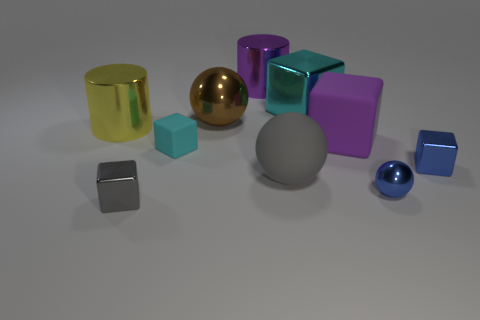Subtract all cyan cubes. How many were subtracted if there are1cyan cubes left? 1 Subtract 1 blocks. How many blocks are left? 4 Subtract all tiny cyan cubes. How many cubes are left? 4 Subtract all cyan blocks. How many blocks are left? 3 Subtract all spheres. How many objects are left? 7 Subtract all yellow cubes. Subtract all purple cylinders. How many cubes are left? 5 Add 3 purple matte things. How many purple matte things exist? 4 Subtract 0 red cylinders. How many objects are left? 10 Subtract all purple objects. Subtract all cyan matte blocks. How many objects are left? 7 Add 2 yellow objects. How many yellow objects are left? 3 